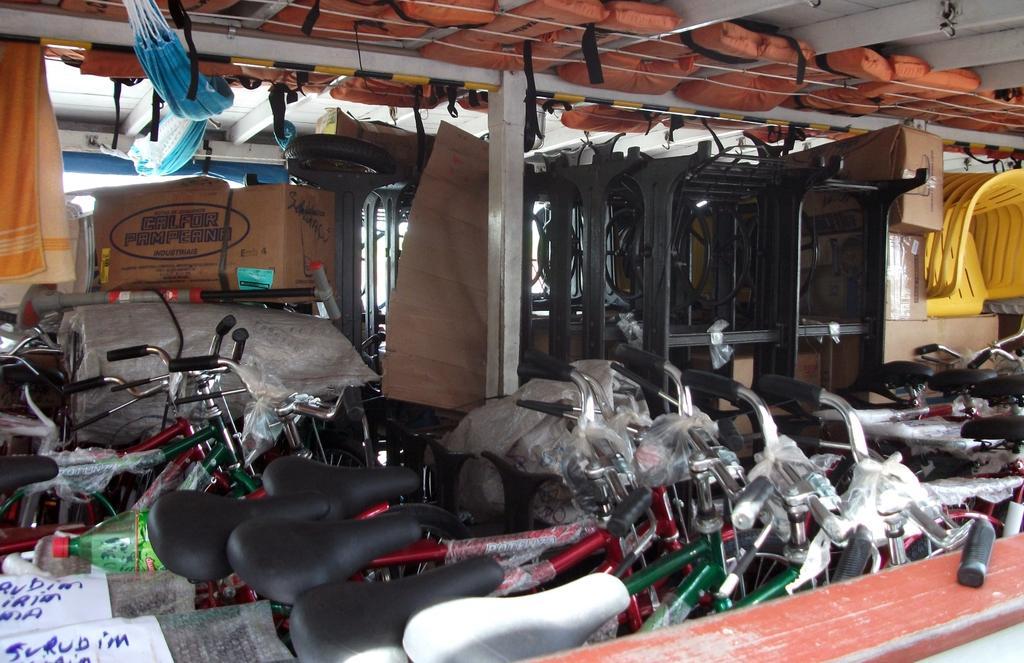In one or two sentences, can you explain what this image depicts? It seems to be a shed. Here I can see many bicycles, metal stands, card boxes and many other items. In the middle of the image there is a pillar. At the top of the image I can see the ceiling. 